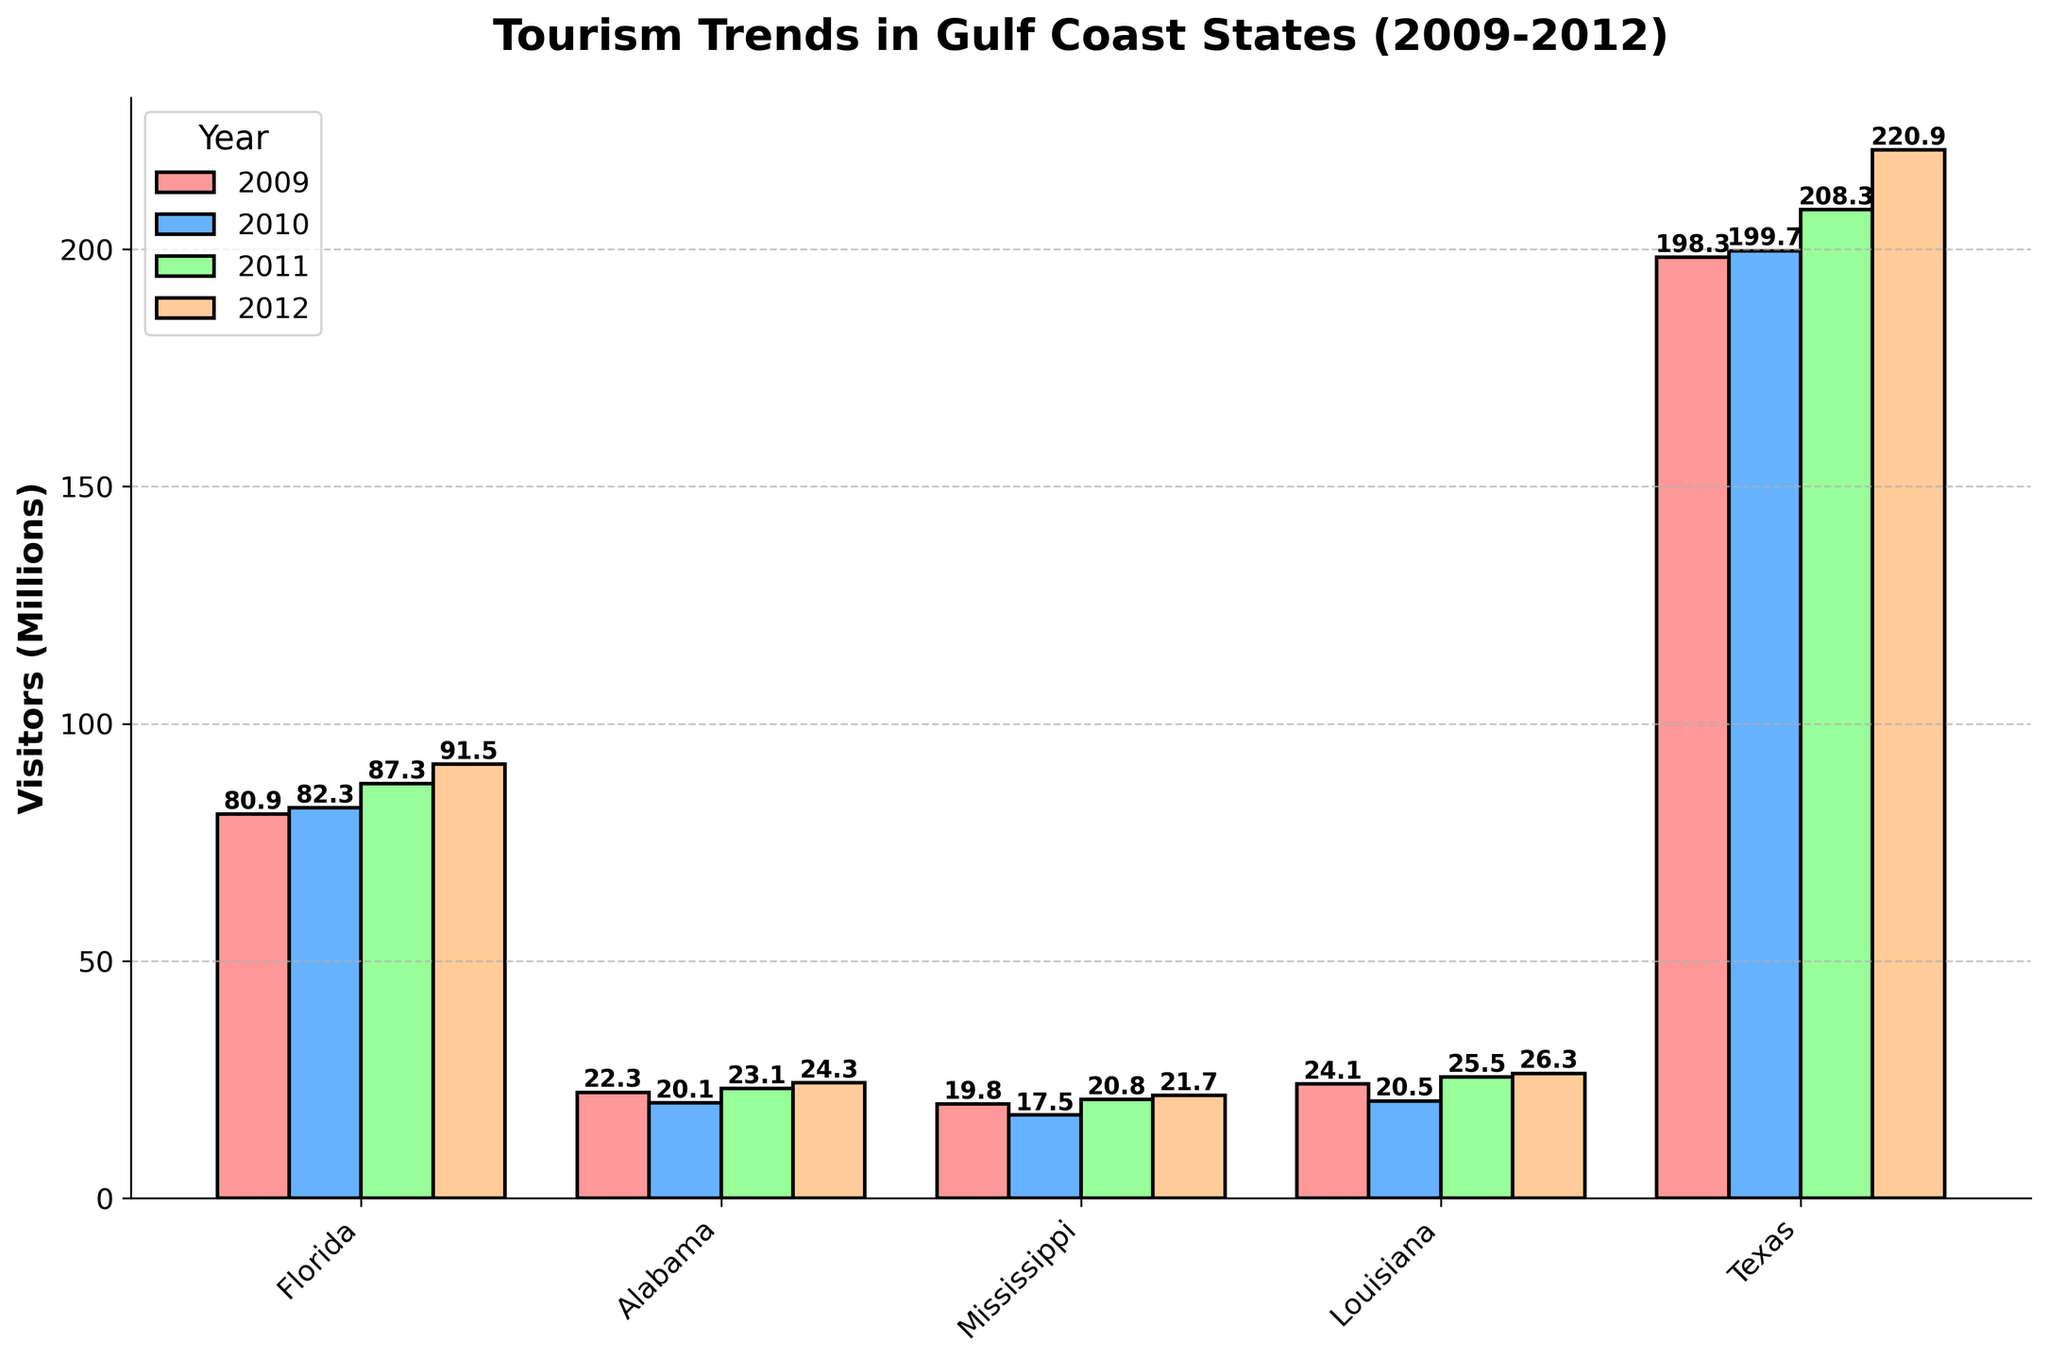What's the trend in the number of visitors in Florida from 2009 to 2012? To identify the trend, observe the height of the bars for Florida from 2009 to 2012. The bars gradually increase: 80.9 million (2009), 82.3 million (2010), 87.3 million (2011), 91.5 million (2012).
Answer: Increasing Which state saw a decrease in visitors in 2010 compared to 2009? Compare the heights of the 2009 and 2010 bars for each state. Alabama, Mississippi, and Louisiana show a decrease in visitor numbers in 2010 compared to 2009.
Answer: Alabama, Mississippi, Louisiana What is the difference in the number of visitors between Texas and Mississippi in 2012? Subtract Mississippi’s 2012 visitors from Texas’s 2012 visitors: 220.9 million (Texas) - 21.7 million (Mississippi) = 199.2 million.
Answer: 199.2 million Which state had the highest number of visitors in 2009? Compare the heights of the 2009 bars for all states. Texas has the highest number with 198.3 million visitors.
Answer: Texas What is the average number of visitors in Alabama from 2009 to 2012? Sum Alabama's visitors from 2009 to 2012 and divide by 4: (22.3 + 20.1 + 23.1 + 24.3) / 4 = 22.45 million.
Answer: 22.45 million In which year did Louisiana have the highest number of visitors? Compare the heights of the bars for Louisiana across all years. The highest bar is in 2012 with 26.3 million visitors.
Answer: 2012 What is the total number of visitors in all states combined in 2011? Sum the 2011 visitors for all states: 87.3 (Florida) + 23.1 (Alabama) + 20.8 (Mississippi) + 25.5 (Louisiana) + 208.3 (Texas) = 365 million.
Answer: 365 million Which state had a lower number of visitors in 2011 compared to 2012? Compare 2011 and 2012 bars for each state. All states had an increase in visitor numbers in 2012 compared to 2011.
Answer: None 